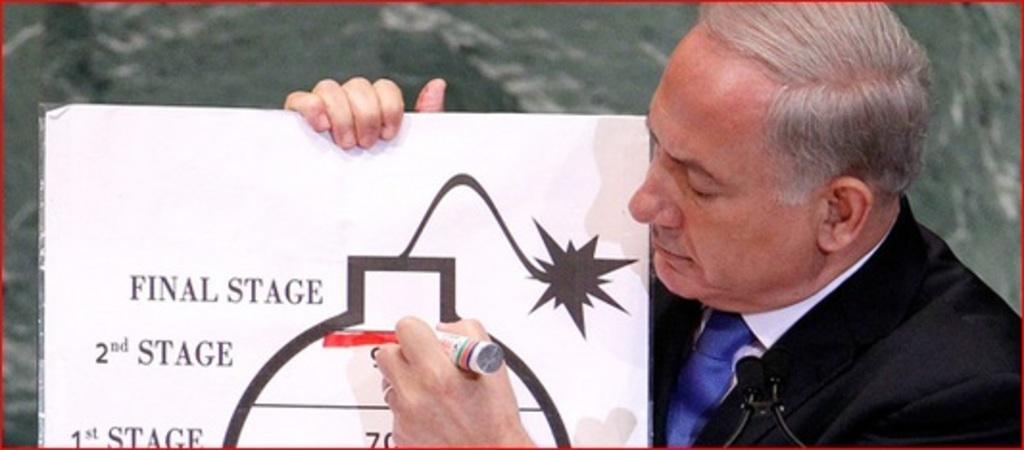Can you describe this image briefly? In the picture i can see a man wearing black color suit, microphone holding some board in his hand and a marker and there are some words written on it. 